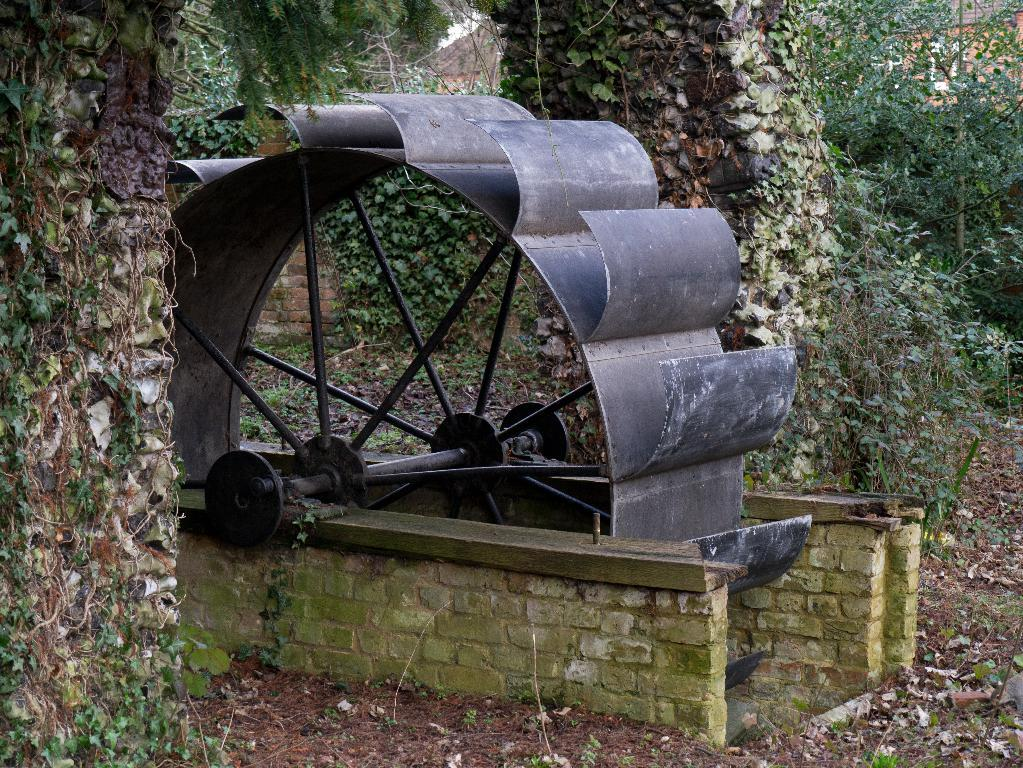What is the main object in the image? There is a machine in the image. What color is the machine? The machine is grey in color. What can be seen in the background of the image? There are many trees in the background of the image. What is visible on the ground in the image? The ground is visible in the image. What type of riddle can be solved by the machine in the image? There is no riddle present in the image, nor does the machine have the ability to solve riddles. How many sticks are being held by the machine in the image? There are no sticks present in the image, and the machine is not holding anything. 